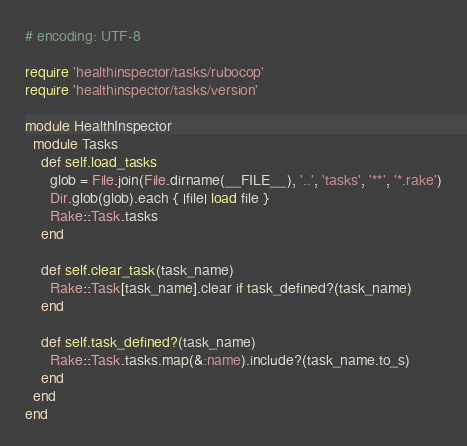<code> <loc_0><loc_0><loc_500><loc_500><_Ruby_># encoding: UTF-8

require 'healthinspector/tasks/rubocop'
require 'healthinspector/tasks/version'

module HealthInspector
  module Tasks
    def self.load_tasks
      glob = File.join(File.dirname(__FILE__), '..', 'tasks', '**', '*.rake')
      Dir.glob(glob).each { |file| load file }
      Rake::Task.tasks
    end

    def self.clear_task(task_name)
      Rake::Task[task_name].clear if task_defined?(task_name)
    end

    def self.task_defined?(task_name)
      Rake::Task.tasks.map(&:name).include?(task_name.to_s)
    end
  end
end
</code> 